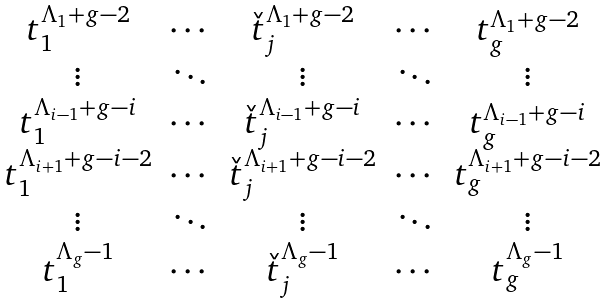Convert formula to latex. <formula><loc_0><loc_0><loc_500><loc_500>\begin{matrix} t _ { 1 } ^ { \Lambda _ { 1 } + g - 2 } & \cdots & \check { t } _ { j } ^ { \Lambda _ { 1 } + g - 2 } & \cdots & t _ { g } ^ { \Lambda _ { 1 } + g - 2 } \\ \vdots & \ddots & \vdots & \ddots & \vdots \\ t _ { 1 } ^ { \Lambda _ { i - 1 } + g - i } & \cdots & \check { t } _ { j } ^ { \Lambda _ { i - 1 } + g - i } & \cdots & t _ { g } ^ { \Lambda _ { i - 1 } + g - i } \\ t _ { 1 } ^ { \Lambda _ { i + 1 } + g - i - 2 } & \cdots & \check { t } _ { j } ^ { \Lambda _ { i + 1 } + g - i - 2 } & \cdots & t _ { g } ^ { \Lambda _ { i + 1 } + g - i - 2 } \\ \vdots & \ddots & \vdots & \ddots & \vdots \\ t _ { 1 } ^ { \Lambda _ { g } - 1 } & \cdots & \check { t } _ { j } ^ { \Lambda _ { g } - 1 } & \cdots & t _ { g } ^ { \Lambda _ { g } - 1 } \\ \end{matrix}</formula> 